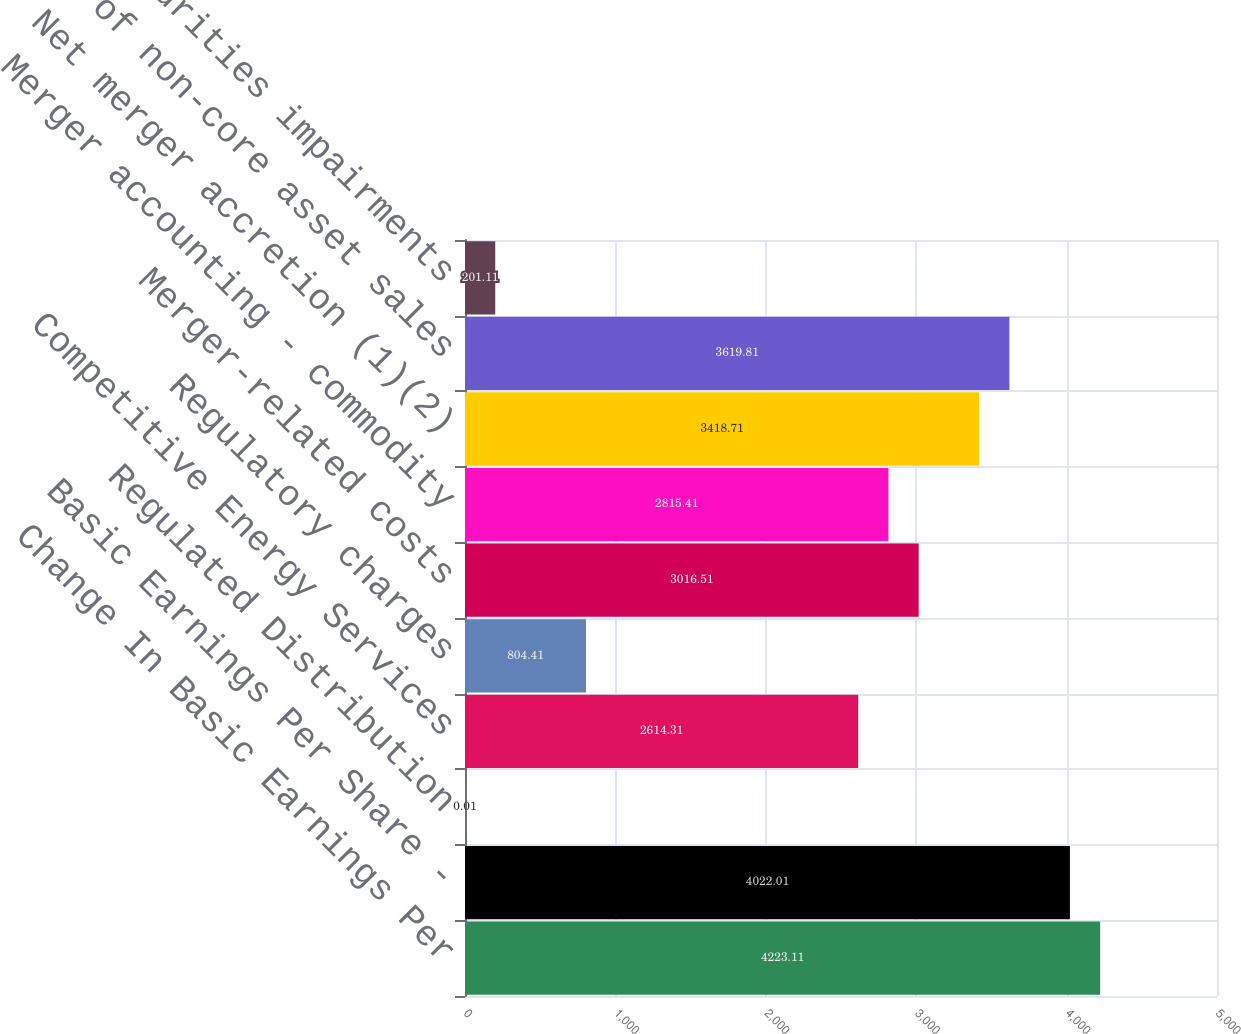Convert chart to OTSL. <chart><loc_0><loc_0><loc_500><loc_500><bar_chart><fcel>Change In Basic Earnings Per<fcel>Basic Earnings Per Share -<fcel>Regulated Distribution<fcel>Competitive Energy Services<fcel>Regulatory charges<fcel>Merger-related costs<fcel>Merger accounting - commodity<fcel>Net merger accretion (1)(2)<fcel>Impact of non-core asset sales<fcel>Trust securities impairments<nl><fcel>4223.11<fcel>4022.01<fcel>0.01<fcel>2614.31<fcel>804.41<fcel>3016.51<fcel>2815.41<fcel>3418.71<fcel>3619.81<fcel>201.11<nl></chart> 